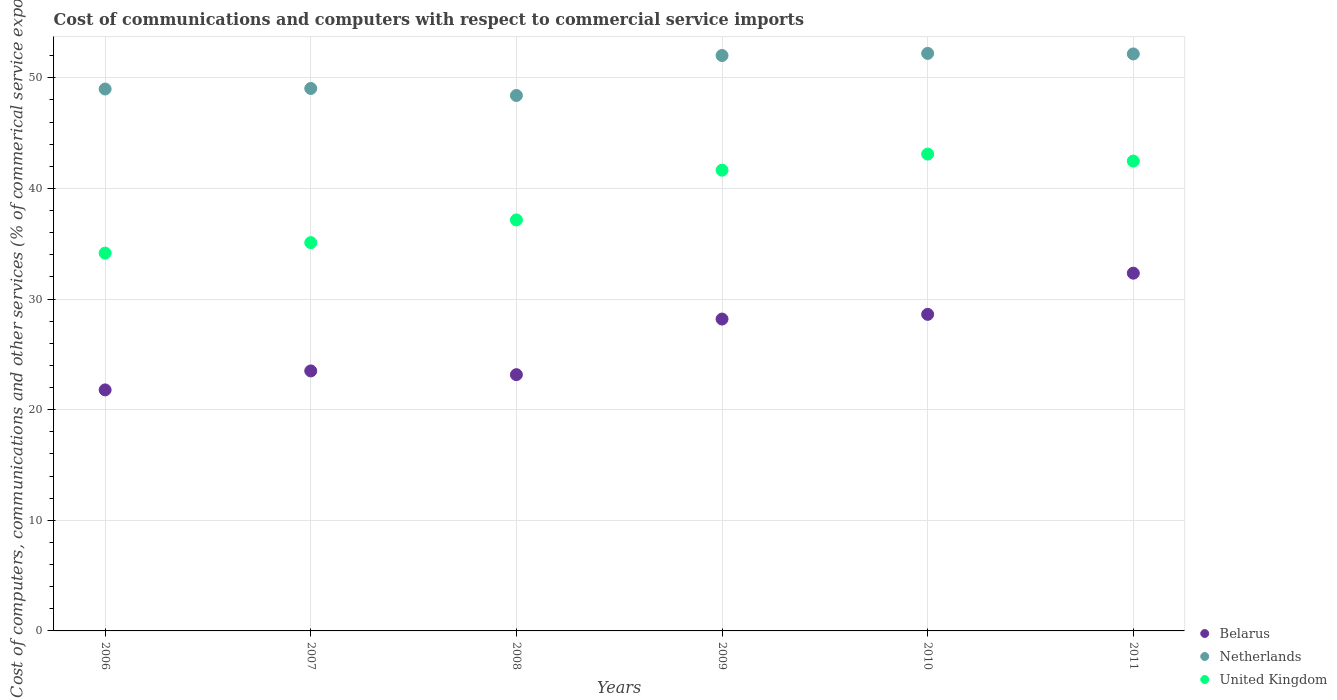How many different coloured dotlines are there?
Keep it short and to the point. 3. Is the number of dotlines equal to the number of legend labels?
Make the answer very short. Yes. What is the cost of communications and computers in United Kingdom in 2008?
Your answer should be very brief. 37.16. Across all years, what is the maximum cost of communications and computers in Belarus?
Offer a terse response. 32.34. Across all years, what is the minimum cost of communications and computers in Belarus?
Ensure brevity in your answer.  21.79. In which year was the cost of communications and computers in Belarus minimum?
Offer a terse response. 2006. What is the total cost of communications and computers in Belarus in the graph?
Keep it short and to the point. 157.61. What is the difference between the cost of communications and computers in United Kingdom in 2006 and that in 2009?
Keep it short and to the point. -7.5. What is the difference between the cost of communications and computers in United Kingdom in 2009 and the cost of communications and computers in Netherlands in 2007?
Your answer should be compact. -7.39. What is the average cost of communications and computers in Netherlands per year?
Offer a very short reply. 50.47. In the year 2008, what is the difference between the cost of communications and computers in Belarus and cost of communications and computers in United Kingdom?
Your answer should be very brief. -13.99. What is the ratio of the cost of communications and computers in Netherlands in 2007 to that in 2010?
Provide a short and direct response. 0.94. Is the cost of communications and computers in Netherlands in 2008 less than that in 2009?
Offer a terse response. Yes. Is the difference between the cost of communications and computers in Belarus in 2006 and 2011 greater than the difference between the cost of communications and computers in United Kingdom in 2006 and 2011?
Ensure brevity in your answer.  No. What is the difference between the highest and the second highest cost of communications and computers in United Kingdom?
Keep it short and to the point. 0.63. What is the difference between the highest and the lowest cost of communications and computers in Belarus?
Ensure brevity in your answer.  10.55. Is it the case that in every year, the sum of the cost of communications and computers in United Kingdom and cost of communications and computers in Netherlands  is greater than the cost of communications and computers in Belarus?
Keep it short and to the point. Yes. How many dotlines are there?
Keep it short and to the point. 3. How many years are there in the graph?
Your answer should be compact. 6. What is the difference between two consecutive major ticks on the Y-axis?
Your answer should be very brief. 10. Are the values on the major ticks of Y-axis written in scientific E-notation?
Ensure brevity in your answer.  No. Does the graph contain grids?
Provide a succinct answer. Yes. Where does the legend appear in the graph?
Provide a short and direct response. Bottom right. How are the legend labels stacked?
Ensure brevity in your answer.  Vertical. What is the title of the graph?
Your answer should be very brief. Cost of communications and computers with respect to commercial service imports. What is the label or title of the Y-axis?
Ensure brevity in your answer.  Cost of computers, communications and other services (% of commerical service exports). What is the Cost of computers, communications and other services (% of commerical service exports) in Belarus in 2006?
Provide a succinct answer. 21.79. What is the Cost of computers, communications and other services (% of commerical service exports) in Netherlands in 2006?
Ensure brevity in your answer.  48.99. What is the Cost of computers, communications and other services (% of commerical service exports) of United Kingdom in 2006?
Provide a short and direct response. 34.16. What is the Cost of computers, communications and other services (% of commerical service exports) in Belarus in 2007?
Make the answer very short. 23.5. What is the Cost of computers, communications and other services (% of commerical service exports) of Netherlands in 2007?
Give a very brief answer. 49.04. What is the Cost of computers, communications and other services (% of commerical service exports) in United Kingdom in 2007?
Ensure brevity in your answer.  35.1. What is the Cost of computers, communications and other services (% of commerical service exports) of Belarus in 2008?
Provide a short and direct response. 23.17. What is the Cost of computers, communications and other services (% of commerical service exports) in Netherlands in 2008?
Give a very brief answer. 48.4. What is the Cost of computers, communications and other services (% of commerical service exports) of United Kingdom in 2008?
Your answer should be compact. 37.16. What is the Cost of computers, communications and other services (% of commerical service exports) of Belarus in 2009?
Offer a very short reply. 28.19. What is the Cost of computers, communications and other services (% of commerical service exports) of Netherlands in 2009?
Make the answer very short. 52.02. What is the Cost of computers, communications and other services (% of commerical service exports) in United Kingdom in 2009?
Your answer should be very brief. 41.65. What is the Cost of computers, communications and other services (% of commerical service exports) of Belarus in 2010?
Provide a succinct answer. 28.62. What is the Cost of computers, communications and other services (% of commerical service exports) in Netherlands in 2010?
Your response must be concise. 52.21. What is the Cost of computers, communications and other services (% of commerical service exports) in United Kingdom in 2010?
Your response must be concise. 43.11. What is the Cost of computers, communications and other services (% of commerical service exports) of Belarus in 2011?
Offer a terse response. 32.34. What is the Cost of computers, communications and other services (% of commerical service exports) in Netherlands in 2011?
Provide a short and direct response. 52.16. What is the Cost of computers, communications and other services (% of commerical service exports) in United Kingdom in 2011?
Offer a very short reply. 42.48. Across all years, what is the maximum Cost of computers, communications and other services (% of commerical service exports) of Belarus?
Keep it short and to the point. 32.34. Across all years, what is the maximum Cost of computers, communications and other services (% of commerical service exports) of Netherlands?
Provide a short and direct response. 52.21. Across all years, what is the maximum Cost of computers, communications and other services (% of commerical service exports) in United Kingdom?
Provide a succinct answer. 43.11. Across all years, what is the minimum Cost of computers, communications and other services (% of commerical service exports) in Belarus?
Ensure brevity in your answer.  21.79. Across all years, what is the minimum Cost of computers, communications and other services (% of commerical service exports) of Netherlands?
Ensure brevity in your answer.  48.4. Across all years, what is the minimum Cost of computers, communications and other services (% of commerical service exports) in United Kingdom?
Give a very brief answer. 34.16. What is the total Cost of computers, communications and other services (% of commerical service exports) in Belarus in the graph?
Keep it short and to the point. 157.61. What is the total Cost of computers, communications and other services (% of commerical service exports) in Netherlands in the graph?
Provide a succinct answer. 302.82. What is the total Cost of computers, communications and other services (% of commerical service exports) of United Kingdom in the graph?
Keep it short and to the point. 233.65. What is the difference between the Cost of computers, communications and other services (% of commerical service exports) in Belarus in 2006 and that in 2007?
Keep it short and to the point. -1.72. What is the difference between the Cost of computers, communications and other services (% of commerical service exports) in Netherlands in 2006 and that in 2007?
Make the answer very short. -0.05. What is the difference between the Cost of computers, communications and other services (% of commerical service exports) in United Kingdom in 2006 and that in 2007?
Keep it short and to the point. -0.95. What is the difference between the Cost of computers, communications and other services (% of commerical service exports) in Belarus in 2006 and that in 2008?
Keep it short and to the point. -1.38. What is the difference between the Cost of computers, communications and other services (% of commerical service exports) of Netherlands in 2006 and that in 2008?
Provide a succinct answer. 0.59. What is the difference between the Cost of computers, communications and other services (% of commerical service exports) of United Kingdom in 2006 and that in 2008?
Your answer should be compact. -3. What is the difference between the Cost of computers, communications and other services (% of commerical service exports) in Belarus in 2006 and that in 2009?
Offer a terse response. -6.41. What is the difference between the Cost of computers, communications and other services (% of commerical service exports) of Netherlands in 2006 and that in 2009?
Offer a very short reply. -3.03. What is the difference between the Cost of computers, communications and other services (% of commerical service exports) in United Kingdom in 2006 and that in 2009?
Provide a short and direct response. -7.5. What is the difference between the Cost of computers, communications and other services (% of commerical service exports) in Belarus in 2006 and that in 2010?
Your answer should be very brief. -6.83. What is the difference between the Cost of computers, communications and other services (% of commerical service exports) in Netherlands in 2006 and that in 2010?
Your answer should be very brief. -3.22. What is the difference between the Cost of computers, communications and other services (% of commerical service exports) in United Kingdom in 2006 and that in 2010?
Offer a very short reply. -8.95. What is the difference between the Cost of computers, communications and other services (% of commerical service exports) in Belarus in 2006 and that in 2011?
Offer a very short reply. -10.55. What is the difference between the Cost of computers, communications and other services (% of commerical service exports) of Netherlands in 2006 and that in 2011?
Offer a terse response. -3.17. What is the difference between the Cost of computers, communications and other services (% of commerical service exports) of United Kingdom in 2006 and that in 2011?
Your response must be concise. -8.32. What is the difference between the Cost of computers, communications and other services (% of commerical service exports) of Belarus in 2007 and that in 2008?
Your answer should be very brief. 0.34. What is the difference between the Cost of computers, communications and other services (% of commerical service exports) of Netherlands in 2007 and that in 2008?
Provide a short and direct response. 0.64. What is the difference between the Cost of computers, communications and other services (% of commerical service exports) in United Kingdom in 2007 and that in 2008?
Give a very brief answer. -2.05. What is the difference between the Cost of computers, communications and other services (% of commerical service exports) of Belarus in 2007 and that in 2009?
Keep it short and to the point. -4.69. What is the difference between the Cost of computers, communications and other services (% of commerical service exports) in Netherlands in 2007 and that in 2009?
Make the answer very short. -2.98. What is the difference between the Cost of computers, communications and other services (% of commerical service exports) of United Kingdom in 2007 and that in 2009?
Offer a terse response. -6.55. What is the difference between the Cost of computers, communications and other services (% of commerical service exports) in Belarus in 2007 and that in 2010?
Offer a terse response. -5.11. What is the difference between the Cost of computers, communications and other services (% of commerical service exports) of Netherlands in 2007 and that in 2010?
Make the answer very short. -3.17. What is the difference between the Cost of computers, communications and other services (% of commerical service exports) in United Kingdom in 2007 and that in 2010?
Ensure brevity in your answer.  -8. What is the difference between the Cost of computers, communications and other services (% of commerical service exports) in Belarus in 2007 and that in 2011?
Ensure brevity in your answer.  -8.84. What is the difference between the Cost of computers, communications and other services (% of commerical service exports) in Netherlands in 2007 and that in 2011?
Your answer should be very brief. -3.12. What is the difference between the Cost of computers, communications and other services (% of commerical service exports) of United Kingdom in 2007 and that in 2011?
Your answer should be very brief. -7.38. What is the difference between the Cost of computers, communications and other services (% of commerical service exports) in Belarus in 2008 and that in 2009?
Provide a short and direct response. -5.03. What is the difference between the Cost of computers, communications and other services (% of commerical service exports) of Netherlands in 2008 and that in 2009?
Your response must be concise. -3.61. What is the difference between the Cost of computers, communications and other services (% of commerical service exports) in United Kingdom in 2008 and that in 2009?
Make the answer very short. -4.5. What is the difference between the Cost of computers, communications and other services (% of commerical service exports) in Belarus in 2008 and that in 2010?
Offer a terse response. -5.45. What is the difference between the Cost of computers, communications and other services (% of commerical service exports) in Netherlands in 2008 and that in 2010?
Offer a terse response. -3.81. What is the difference between the Cost of computers, communications and other services (% of commerical service exports) in United Kingdom in 2008 and that in 2010?
Offer a very short reply. -5.95. What is the difference between the Cost of computers, communications and other services (% of commerical service exports) of Belarus in 2008 and that in 2011?
Offer a terse response. -9.18. What is the difference between the Cost of computers, communications and other services (% of commerical service exports) of Netherlands in 2008 and that in 2011?
Ensure brevity in your answer.  -3.76. What is the difference between the Cost of computers, communications and other services (% of commerical service exports) in United Kingdom in 2008 and that in 2011?
Make the answer very short. -5.32. What is the difference between the Cost of computers, communications and other services (% of commerical service exports) of Belarus in 2009 and that in 2010?
Your answer should be very brief. -0.43. What is the difference between the Cost of computers, communications and other services (% of commerical service exports) in Netherlands in 2009 and that in 2010?
Your answer should be very brief. -0.19. What is the difference between the Cost of computers, communications and other services (% of commerical service exports) in United Kingdom in 2009 and that in 2010?
Provide a succinct answer. -1.45. What is the difference between the Cost of computers, communications and other services (% of commerical service exports) of Belarus in 2009 and that in 2011?
Ensure brevity in your answer.  -4.15. What is the difference between the Cost of computers, communications and other services (% of commerical service exports) of Netherlands in 2009 and that in 2011?
Keep it short and to the point. -0.14. What is the difference between the Cost of computers, communications and other services (% of commerical service exports) in United Kingdom in 2009 and that in 2011?
Give a very brief answer. -0.83. What is the difference between the Cost of computers, communications and other services (% of commerical service exports) of Belarus in 2010 and that in 2011?
Your response must be concise. -3.72. What is the difference between the Cost of computers, communications and other services (% of commerical service exports) of Netherlands in 2010 and that in 2011?
Ensure brevity in your answer.  0.05. What is the difference between the Cost of computers, communications and other services (% of commerical service exports) in United Kingdom in 2010 and that in 2011?
Your response must be concise. 0.63. What is the difference between the Cost of computers, communications and other services (% of commerical service exports) of Belarus in 2006 and the Cost of computers, communications and other services (% of commerical service exports) of Netherlands in 2007?
Your response must be concise. -27.25. What is the difference between the Cost of computers, communications and other services (% of commerical service exports) of Belarus in 2006 and the Cost of computers, communications and other services (% of commerical service exports) of United Kingdom in 2007?
Your answer should be very brief. -13.31. What is the difference between the Cost of computers, communications and other services (% of commerical service exports) in Netherlands in 2006 and the Cost of computers, communications and other services (% of commerical service exports) in United Kingdom in 2007?
Your answer should be very brief. 13.89. What is the difference between the Cost of computers, communications and other services (% of commerical service exports) of Belarus in 2006 and the Cost of computers, communications and other services (% of commerical service exports) of Netherlands in 2008?
Your answer should be very brief. -26.62. What is the difference between the Cost of computers, communications and other services (% of commerical service exports) in Belarus in 2006 and the Cost of computers, communications and other services (% of commerical service exports) in United Kingdom in 2008?
Ensure brevity in your answer.  -15.37. What is the difference between the Cost of computers, communications and other services (% of commerical service exports) of Netherlands in 2006 and the Cost of computers, communications and other services (% of commerical service exports) of United Kingdom in 2008?
Your answer should be compact. 11.83. What is the difference between the Cost of computers, communications and other services (% of commerical service exports) of Belarus in 2006 and the Cost of computers, communications and other services (% of commerical service exports) of Netherlands in 2009?
Ensure brevity in your answer.  -30.23. What is the difference between the Cost of computers, communications and other services (% of commerical service exports) in Belarus in 2006 and the Cost of computers, communications and other services (% of commerical service exports) in United Kingdom in 2009?
Your answer should be very brief. -19.86. What is the difference between the Cost of computers, communications and other services (% of commerical service exports) of Netherlands in 2006 and the Cost of computers, communications and other services (% of commerical service exports) of United Kingdom in 2009?
Offer a terse response. 7.34. What is the difference between the Cost of computers, communications and other services (% of commerical service exports) of Belarus in 2006 and the Cost of computers, communications and other services (% of commerical service exports) of Netherlands in 2010?
Your response must be concise. -30.42. What is the difference between the Cost of computers, communications and other services (% of commerical service exports) in Belarus in 2006 and the Cost of computers, communications and other services (% of commerical service exports) in United Kingdom in 2010?
Give a very brief answer. -21.32. What is the difference between the Cost of computers, communications and other services (% of commerical service exports) in Netherlands in 2006 and the Cost of computers, communications and other services (% of commerical service exports) in United Kingdom in 2010?
Your answer should be compact. 5.88. What is the difference between the Cost of computers, communications and other services (% of commerical service exports) of Belarus in 2006 and the Cost of computers, communications and other services (% of commerical service exports) of Netherlands in 2011?
Your answer should be very brief. -30.37. What is the difference between the Cost of computers, communications and other services (% of commerical service exports) in Belarus in 2006 and the Cost of computers, communications and other services (% of commerical service exports) in United Kingdom in 2011?
Your response must be concise. -20.69. What is the difference between the Cost of computers, communications and other services (% of commerical service exports) in Netherlands in 2006 and the Cost of computers, communications and other services (% of commerical service exports) in United Kingdom in 2011?
Your response must be concise. 6.51. What is the difference between the Cost of computers, communications and other services (% of commerical service exports) of Belarus in 2007 and the Cost of computers, communications and other services (% of commerical service exports) of Netherlands in 2008?
Your answer should be compact. -24.9. What is the difference between the Cost of computers, communications and other services (% of commerical service exports) in Belarus in 2007 and the Cost of computers, communications and other services (% of commerical service exports) in United Kingdom in 2008?
Your answer should be compact. -13.65. What is the difference between the Cost of computers, communications and other services (% of commerical service exports) in Netherlands in 2007 and the Cost of computers, communications and other services (% of commerical service exports) in United Kingdom in 2008?
Make the answer very short. 11.88. What is the difference between the Cost of computers, communications and other services (% of commerical service exports) in Belarus in 2007 and the Cost of computers, communications and other services (% of commerical service exports) in Netherlands in 2009?
Ensure brevity in your answer.  -28.51. What is the difference between the Cost of computers, communications and other services (% of commerical service exports) in Belarus in 2007 and the Cost of computers, communications and other services (% of commerical service exports) in United Kingdom in 2009?
Your answer should be very brief. -18.15. What is the difference between the Cost of computers, communications and other services (% of commerical service exports) of Netherlands in 2007 and the Cost of computers, communications and other services (% of commerical service exports) of United Kingdom in 2009?
Offer a very short reply. 7.39. What is the difference between the Cost of computers, communications and other services (% of commerical service exports) of Belarus in 2007 and the Cost of computers, communications and other services (% of commerical service exports) of Netherlands in 2010?
Give a very brief answer. -28.71. What is the difference between the Cost of computers, communications and other services (% of commerical service exports) in Belarus in 2007 and the Cost of computers, communications and other services (% of commerical service exports) in United Kingdom in 2010?
Keep it short and to the point. -19.6. What is the difference between the Cost of computers, communications and other services (% of commerical service exports) of Netherlands in 2007 and the Cost of computers, communications and other services (% of commerical service exports) of United Kingdom in 2010?
Provide a succinct answer. 5.93. What is the difference between the Cost of computers, communications and other services (% of commerical service exports) in Belarus in 2007 and the Cost of computers, communications and other services (% of commerical service exports) in Netherlands in 2011?
Provide a succinct answer. -28.66. What is the difference between the Cost of computers, communications and other services (% of commerical service exports) of Belarus in 2007 and the Cost of computers, communications and other services (% of commerical service exports) of United Kingdom in 2011?
Keep it short and to the point. -18.97. What is the difference between the Cost of computers, communications and other services (% of commerical service exports) of Netherlands in 2007 and the Cost of computers, communications and other services (% of commerical service exports) of United Kingdom in 2011?
Your answer should be compact. 6.56. What is the difference between the Cost of computers, communications and other services (% of commerical service exports) of Belarus in 2008 and the Cost of computers, communications and other services (% of commerical service exports) of Netherlands in 2009?
Give a very brief answer. -28.85. What is the difference between the Cost of computers, communications and other services (% of commerical service exports) in Belarus in 2008 and the Cost of computers, communications and other services (% of commerical service exports) in United Kingdom in 2009?
Your response must be concise. -18.49. What is the difference between the Cost of computers, communications and other services (% of commerical service exports) in Netherlands in 2008 and the Cost of computers, communications and other services (% of commerical service exports) in United Kingdom in 2009?
Provide a succinct answer. 6.75. What is the difference between the Cost of computers, communications and other services (% of commerical service exports) of Belarus in 2008 and the Cost of computers, communications and other services (% of commerical service exports) of Netherlands in 2010?
Your answer should be compact. -29.04. What is the difference between the Cost of computers, communications and other services (% of commerical service exports) of Belarus in 2008 and the Cost of computers, communications and other services (% of commerical service exports) of United Kingdom in 2010?
Offer a terse response. -19.94. What is the difference between the Cost of computers, communications and other services (% of commerical service exports) in Netherlands in 2008 and the Cost of computers, communications and other services (% of commerical service exports) in United Kingdom in 2010?
Offer a terse response. 5.3. What is the difference between the Cost of computers, communications and other services (% of commerical service exports) in Belarus in 2008 and the Cost of computers, communications and other services (% of commerical service exports) in Netherlands in 2011?
Keep it short and to the point. -28.99. What is the difference between the Cost of computers, communications and other services (% of commerical service exports) of Belarus in 2008 and the Cost of computers, communications and other services (% of commerical service exports) of United Kingdom in 2011?
Provide a succinct answer. -19.31. What is the difference between the Cost of computers, communications and other services (% of commerical service exports) of Netherlands in 2008 and the Cost of computers, communications and other services (% of commerical service exports) of United Kingdom in 2011?
Make the answer very short. 5.93. What is the difference between the Cost of computers, communications and other services (% of commerical service exports) in Belarus in 2009 and the Cost of computers, communications and other services (% of commerical service exports) in Netherlands in 2010?
Your response must be concise. -24.02. What is the difference between the Cost of computers, communications and other services (% of commerical service exports) of Belarus in 2009 and the Cost of computers, communications and other services (% of commerical service exports) of United Kingdom in 2010?
Ensure brevity in your answer.  -14.91. What is the difference between the Cost of computers, communications and other services (% of commerical service exports) in Netherlands in 2009 and the Cost of computers, communications and other services (% of commerical service exports) in United Kingdom in 2010?
Offer a terse response. 8.91. What is the difference between the Cost of computers, communications and other services (% of commerical service exports) of Belarus in 2009 and the Cost of computers, communications and other services (% of commerical service exports) of Netherlands in 2011?
Your answer should be very brief. -23.97. What is the difference between the Cost of computers, communications and other services (% of commerical service exports) in Belarus in 2009 and the Cost of computers, communications and other services (% of commerical service exports) in United Kingdom in 2011?
Your answer should be compact. -14.28. What is the difference between the Cost of computers, communications and other services (% of commerical service exports) of Netherlands in 2009 and the Cost of computers, communications and other services (% of commerical service exports) of United Kingdom in 2011?
Offer a very short reply. 9.54. What is the difference between the Cost of computers, communications and other services (% of commerical service exports) in Belarus in 2010 and the Cost of computers, communications and other services (% of commerical service exports) in Netherlands in 2011?
Your answer should be compact. -23.54. What is the difference between the Cost of computers, communications and other services (% of commerical service exports) of Belarus in 2010 and the Cost of computers, communications and other services (% of commerical service exports) of United Kingdom in 2011?
Provide a succinct answer. -13.86. What is the difference between the Cost of computers, communications and other services (% of commerical service exports) in Netherlands in 2010 and the Cost of computers, communications and other services (% of commerical service exports) in United Kingdom in 2011?
Make the answer very short. 9.73. What is the average Cost of computers, communications and other services (% of commerical service exports) in Belarus per year?
Provide a short and direct response. 26.27. What is the average Cost of computers, communications and other services (% of commerical service exports) in Netherlands per year?
Your response must be concise. 50.47. What is the average Cost of computers, communications and other services (% of commerical service exports) in United Kingdom per year?
Provide a short and direct response. 38.94. In the year 2006, what is the difference between the Cost of computers, communications and other services (% of commerical service exports) in Belarus and Cost of computers, communications and other services (% of commerical service exports) in Netherlands?
Your response must be concise. -27.2. In the year 2006, what is the difference between the Cost of computers, communications and other services (% of commerical service exports) of Belarus and Cost of computers, communications and other services (% of commerical service exports) of United Kingdom?
Your response must be concise. -12.37. In the year 2006, what is the difference between the Cost of computers, communications and other services (% of commerical service exports) of Netherlands and Cost of computers, communications and other services (% of commerical service exports) of United Kingdom?
Your answer should be compact. 14.83. In the year 2007, what is the difference between the Cost of computers, communications and other services (% of commerical service exports) of Belarus and Cost of computers, communications and other services (% of commerical service exports) of Netherlands?
Give a very brief answer. -25.54. In the year 2007, what is the difference between the Cost of computers, communications and other services (% of commerical service exports) of Belarus and Cost of computers, communications and other services (% of commerical service exports) of United Kingdom?
Ensure brevity in your answer.  -11.6. In the year 2007, what is the difference between the Cost of computers, communications and other services (% of commerical service exports) of Netherlands and Cost of computers, communications and other services (% of commerical service exports) of United Kingdom?
Keep it short and to the point. 13.94. In the year 2008, what is the difference between the Cost of computers, communications and other services (% of commerical service exports) of Belarus and Cost of computers, communications and other services (% of commerical service exports) of Netherlands?
Your answer should be very brief. -25.24. In the year 2008, what is the difference between the Cost of computers, communications and other services (% of commerical service exports) of Belarus and Cost of computers, communications and other services (% of commerical service exports) of United Kingdom?
Your answer should be compact. -13.99. In the year 2008, what is the difference between the Cost of computers, communications and other services (% of commerical service exports) of Netherlands and Cost of computers, communications and other services (% of commerical service exports) of United Kingdom?
Provide a succinct answer. 11.25. In the year 2009, what is the difference between the Cost of computers, communications and other services (% of commerical service exports) in Belarus and Cost of computers, communications and other services (% of commerical service exports) in Netherlands?
Ensure brevity in your answer.  -23.83. In the year 2009, what is the difference between the Cost of computers, communications and other services (% of commerical service exports) in Belarus and Cost of computers, communications and other services (% of commerical service exports) in United Kingdom?
Provide a succinct answer. -13.46. In the year 2009, what is the difference between the Cost of computers, communications and other services (% of commerical service exports) in Netherlands and Cost of computers, communications and other services (% of commerical service exports) in United Kingdom?
Make the answer very short. 10.37. In the year 2010, what is the difference between the Cost of computers, communications and other services (% of commerical service exports) of Belarus and Cost of computers, communications and other services (% of commerical service exports) of Netherlands?
Give a very brief answer. -23.59. In the year 2010, what is the difference between the Cost of computers, communications and other services (% of commerical service exports) in Belarus and Cost of computers, communications and other services (% of commerical service exports) in United Kingdom?
Your answer should be very brief. -14.49. In the year 2010, what is the difference between the Cost of computers, communications and other services (% of commerical service exports) of Netherlands and Cost of computers, communications and other services (% of commerical service exports) of United Kingdom?
Make the answer very short. 9.1. In the year 2011, what is the difference between the Cost of computers, communications and other services (% of commerical service exports) of Belarus and Cost of computers, communications and other services (% of commerical service exports) of Netherlands?
Give a very brief answer. -19.82. In the year 2011, what is the difference between the Cost of computers, communications and other services (% of commerical service exports) in Belarus and Cost of computers, communications and other services (% of commerical service exports) in United Kingdom?
Offer a very short reply. -10.14. In the year 2011, what is the difference between the Cost of computers, communications and other services (% of commerical service exports) in Netherlands and Cost of computers, communications and other services (% of commerical service exports) in United Kingdom?
Your response must be concise. 9.68. What is the ratio of the Cost of computers, communications and other services (% of commerical service exports) of Belarus in 2006 to that in 2007?
Give a very brief answer. 0.93. What is the ratio of the Cost of computers, communications and other services (% of commerical service exports) of Netherlands in 2006 to that in 2007?
Your answer should be very brief. 1. What is the ratio of the Cost of computers, communications and other services (% of commerical service exports) of United Kingdom in 2006 to that in 2007?
Give a very brief answer. 0.97. What is the ratio of the Cost of computers, communications and other services (% of commerical service exports) of Belarus in 2006 to that in 2008?
Give a very brief answer. 0.94. What is the ratio of the Cost of computers, communications and other services (% of commerical service exports) of Netherlands in 2006 to that in 2008?
Your response must be concise. 1.01. What is the ratio of the Cost of computers, communications and other services (% of commerical service exports) of United Kingdom in 2006 to that in 2008?
Ensure brevity in your answer.  0.92. What is the ratio of the Cost of computers, communications and other services (% of commerical service exports) in Belarus in 2006 to that in 2009?
Offer a terse response. 0.77. What is the ratio of the Cost of computers, communications and other services (% of commerical service exports) of Netherlands in 2006 to that in 2009?
Your response must be concise. 0.94. What is the ratio of the Cost of computers, communications and other services (% of commerical service exports) in United Kingdom in 2006 to that in 2009?
Your answer should be compact. 0.82. What is the ratio of the Cost of computers, communications and other services (% of commerical service exports) in Belarus in 2006 to that in 2010?
Offer a terse response. 0.76. What is the ratio of the Cost of computers, communications and other services (% of commerical service exports) in Netherlands in 2006 to that in 2010?
Make the answer very short. 0.94. What is the ratio of the Cost of computers, communications and other services (% of commerical service exports) of United Kingdom in 2006 to that in 2010?
Make the answer very short. 0.79. What is the ratio of the Cost of computers, communications and other services (% of commerical service exports) in Belarus in 2006 to that in 2011?
Ensure brevity in your answer.  0.67. What is the ratio of the Cost of computers, communications and other services (% of commerical service exports) of Netherlands in 2006 to that in 2011?
Offer a terse response. 0.94. What is the ratio of the Cost of computers, communications and other services (% of commerical service exports) in United Kingdom in 2006 to that in 2011?
Offer a very short reply. 0.8. What is the ratio of the Cost of computers, communications and other services (% of commerical service exports) in Belarus in 2007 to that in 2008?
Give a very brief answer. 1.01. What is the ratio of the Cost of computers, communications and other services (% of commerical service exports) in Netherlands in 2007 to that in 2008?
Provide a short and direct response. 1.01. What is the ratio of the Cost of computers, communications and other services (% of commerical service exports) in United Kingdom in 2007 to that in 2008?
Provide a succinct answer. 0.94. What is the ratio of the Cost of computers, communications and other services (% of commerical service exports) of Belarus in 2007 to that in 2009?
Your response must be concise. 0.83. What is the ratio of the Cost of computers, communications and other services (% of commerical service exports) in Netherlands in 2007 to that in 2009?
Keep it short and to the point. 0.94. What is the ratio of the Cost of computers, communications and other services (% of commerical service exports) of United Kingdom in 2007 to that in 2009?
Keep it short and to the point. 0.84. What is the ratio of the Cost of computers, communications and other services (% of commerical service exports) in Belarus in 2007 to that in 2010?
Keep it short and to the point. 0.82. What is the ratio of the Cost of computers, communications and other services (% of commerical service exports) of Netherlands in 2007 to that in 2010?
Give a very brief answer. 0.94. What is the ratio of the Cost of computers, communications and other services (% of commerical service exports) of United Kingdom in 2007 to that in 2010?
Offer a terse response. 0.81. What is the ratio of the Cost of computers, communications and other services (% of commerical service exports) in Belarus in 2007 to that in 2011?
Make the answer very short. 0.73. What is the ratio of the Cost of computers, communications and other services (% of commerical service exports) of Netherlands in 2007 to that in 2011?
Offer a terse response. 0.94. What is the ratio of the Cost of computers, communications and other services (% of commerical service exports) of United Kingdom in 2007 to that in 2011?
Ensure brevity in your answer.  0.83. What is the ratio of the Cost of computers, communications and other services (% of commerical service exports) in Belarus in 2008 to that in 2009?
Offer a very short reply. 0.82. What is the ratio of the Cost of computers, communications and other services (% of commerical service exports) in Netherlands in 2008 to that in 2009?
Ensure brevity in your answer.  0.93. What is the ratio of the Cost of computers, communications and other services (% of commerical service exports) in United Kingdom in 2008 to that in 2009?
Ensure brevity in your answer.  0.89. What is the ratio of the Cost of computers, communications and other services (% of commerical service exports) in Belarus in 2008 to that in 2010?
Your answer should be very brief. 0.81. What is the ratio of the Cost of computers, communications and other services (% of commerical service exports) in Netherlands in 2008 to that in 2010?
Make the answer very short. 0.93. What is the ratio of the Cost of computers, communications and other services (% of commerical service exports) in United Kingdom in 2008 to that in 2010?
Provide a succinct answer. 0.86. What is the ratio of the Cost of computers, communications and other services (% of commerical service exports) in Belarus in 2008 to that in 2011?
Offer a very short reply. 0.72. What is the ratio of the Cost of computers, communications and other services (% of commerical service exports) in Netherlands in 2008 to that in 2011?
Provide a short and direct response. 0.93. What is the ratio of the Cost of computers, communications and other services (% of commerical service exports) of United Kingdom in 2008 to that in 2011?
Your response must be concise. 0.87. What is the ratio of the Cost of computers, communications and other services (% of commerical service exports) of Belarus in 2009 to that in 2010?
Offer a terse response. 0.99. What is the ratio of the Cost of computers, communications and other services (% of commerical service exports) in Netherlands in 2009 to that in 2010?
Offer a very short reply. 1. What is the ratio of the Cost of computers, communications and other services (% of commerical service exports) of United Kingdom in 2009 to that in 2010?
Your response must be concise. 0.97. What is the ratio of the Cost of computers, communications and other services (% of commerical service exports) in Belarus in 2009 to that in 2011?
Ensure brevity in your answer.  0.87. What is the ratio of the Cost of computers, communications and other services (% of commerical service exports) in United Kingdom in 2009 to that in 2011?
Keep it short and to the point. 0.98. What is the ratio of the Cost of computers, communications and other services (% of commerical service exports) in Belarus in 2010 to that in 2011?
Keep it short and to the point. 0.88. What is the ratio of the Cost of computers, communications and other services (% of commerical service exports) of United Kingdom in 2010 to that in 2011?
Make the answer very short. 1.01. What is the difference between the highest and the second highest Cost of computers, communications and other services (% of commerical service exports) of Belarus?
Offer a very short reply. 3.72. What is the difference between the highest and the second highest Cost of computers, communications and other services (% of commerical service exports) of Netherlands?
Ensure brevity in your answer.  0.05. What is the difference between the highest and the second highest Cost of computers, communications and other services (% of commerical service exports) of United Kingdom?
Make the answer very short. 0.63. What is the difference between the highest and the lowest Cost of computers, communications and other services (% of commerical service exports) of Belarus?
Ensure brevity in your answer.  10.55. What is the difference between the highest and the lowest Cost of computers, communications and other services (% of commerical service exports) in Netherlands?
Your response must be concise. 3.81. What is the difference between the highest and the lowest Cost of computers, communications and other services (% of commerical service exports) in United Kingdom?
Make the answer very short. 8.95. 